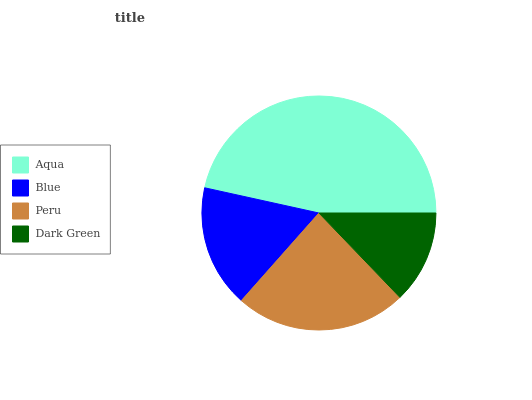Is Dark Green the minimum?
Answer yes or no. Yes. Is Aqua the maximum?
Answer yes or no. Yes. Is Blue the minimum?
Answer yes or no. No. Is Blue the maximum?
Answer yes or no. No. Is Aqua greater than Blue?
Answer yes or no. Yes. Is Blue less than Aqua?
Answer yes or no. Yes. Is Blue greater than Aqua?
Answer yes or no. No. Is Aqua less than Blue?
Answer yes or no. No. Is Peru the high median?
Answer yes or no. Yes. Is Blue the low median?
Answer yes or no. Yes. Is Dark Green the high median?
Answer yes or no. No. Is Dark Green the low median?
Answer yes or no. No. 